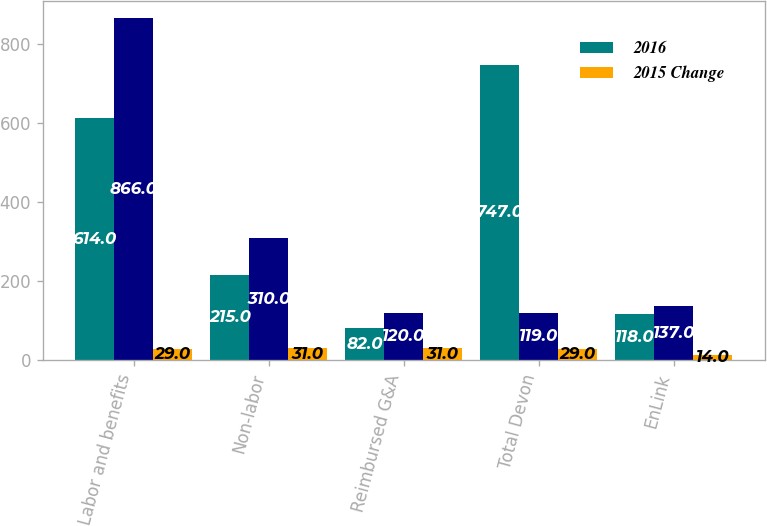Convert chart. <chart><loc_0><loc_0><loc_500><loc_500><stacked_bar_chart><ecel><fcel>Labor and benefits<fcel>Non-labor<fcel>Reimbursed G&A<fcel>Total Devon<fcel>EnLink<nl><fcel>2016<fcel>614<fcel>215<fcel>82<fcel>747<fcel>118<nl><fcel>nan<fcel>866<fcel>310<fcel>120<fcel>119<fcel>137<nl><fcel>2015 Change<fcel>29<fcel>31<fcel>31<fcel>29<fcel>14<nl></chart> 